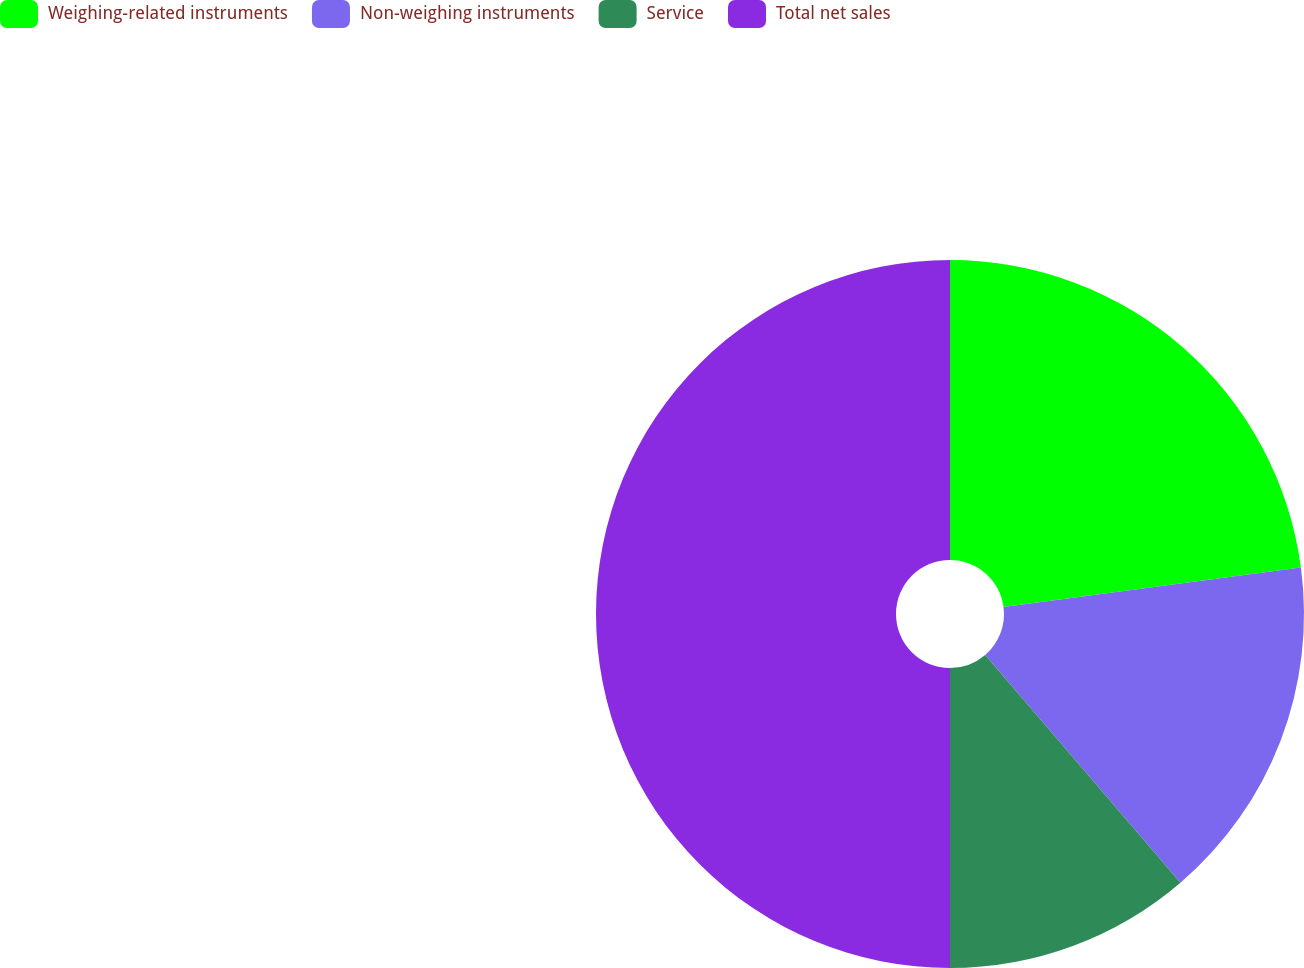Convert chart. <chart><loc_0><loc_0><loc_500><loc_500><pie_chart><fcel>Weighing-related instruments<fcel>Non-weighing instruments<fcel>Service<fcel>Total net sales<nl><fcel>22.9%<fcel>15.82%<fcel>11.28%<fcel>50.0%<nl></chart> 